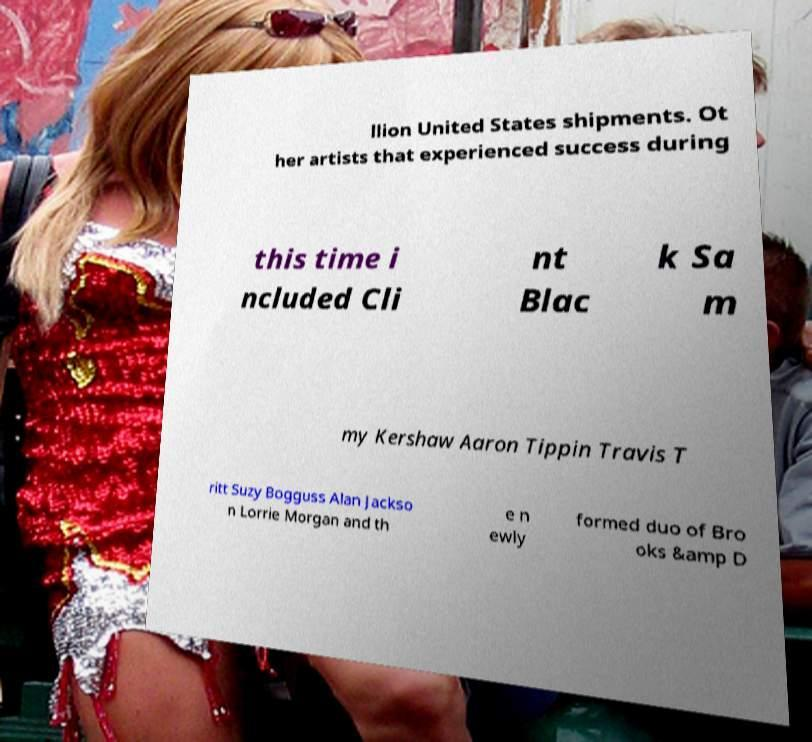There's text embedded in this image that I need extracted. Can you transcribe it verbatim? llion United States shipments. Ot her artists that experienced success during this time i ncluded Cli nt Blac k Sa m my Kershaw Aaron Tippin Travis T ritt Suzy Bogguss Alan Jackso n Lorrie Morgan and th e n ewly formed duo of Bro oks &amp D 